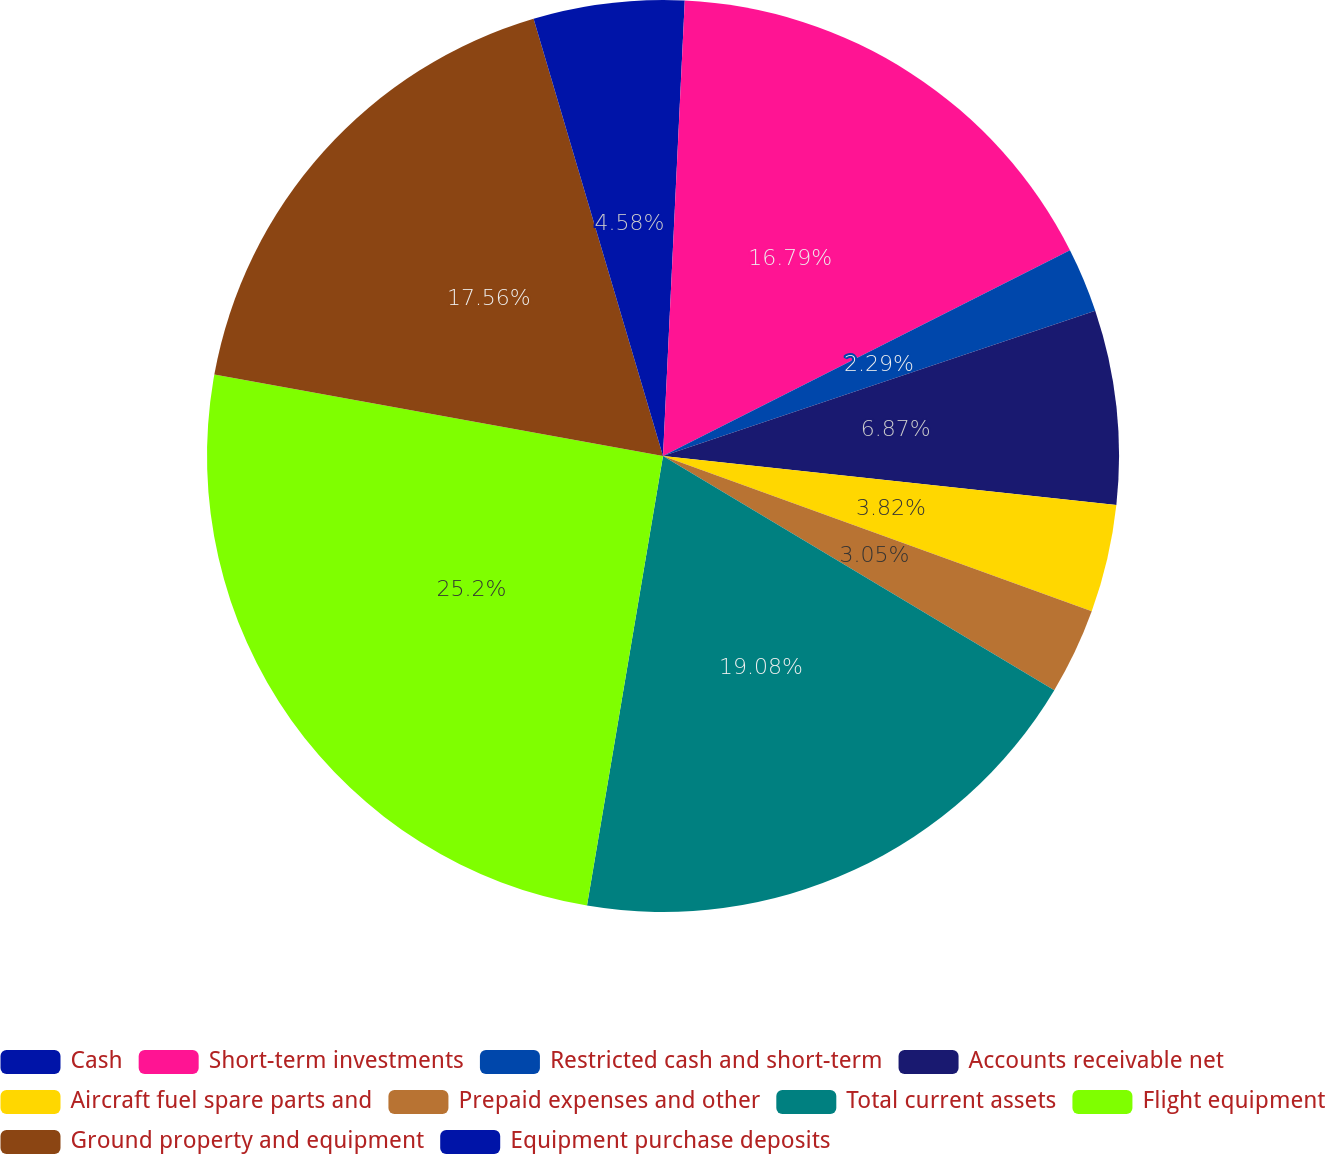<chart> <loc_0><loc_0><loc_500><loc_500><pie_chart><fcel>Cash<fcel>Short-term investments<fcel>Restricted cash and short-term<fcel>Accounts receivable net<fcel>Aircraft fuel spare parts and<fcel>Prepaid expenses and other<fcel>Total current assets<fcel>Flight equipment<fcel>Ground property and equipment<fcel>Equipment purchase deposits<nl><fcel>0.76%<fcel>16.79%<fcel>2.29%<fcel>6.87%<fcel>3.82%<fcel>3.05%<fcel>19.08%<fcel>25.19%<fcel>17.56%<fcel>4.58%<nl></chart> 